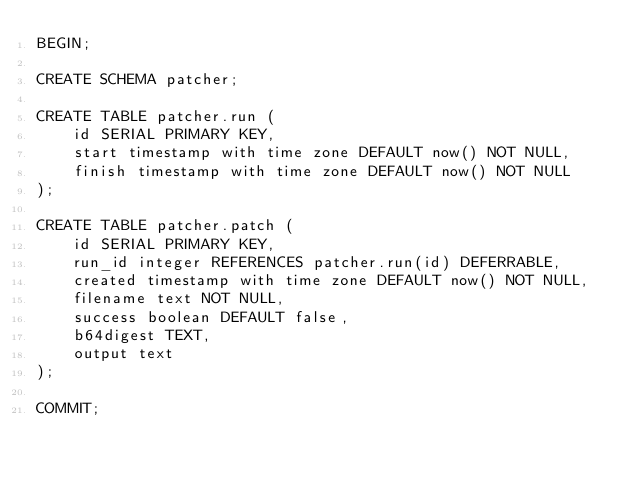Convert code to text. <code><loc_0><loc_0><loc_500><loc_500><_SQL_>BEGIN;

CREATE SCHEMA patcher;

CREATE TABLE patcher.run (
    id SERIAL PRIMARY KEY,
    start timestamp with time zone DEFAULT now() NOT NULL,
    finish timestamp with time zone DEFAULT now() NOT NULL
);

CREATE TABLE patcher.patch (
    id SERIAL PRIMARY KEY,
    run_id integer REFERENCES patcher.run(id) DEFERRABLE,
    created timestamp with time zone DEFAULT now() NOT NULL,
    filename text NOT NULL,
    success boolean DEFAULT false,
    b64digest TEXT,
    output text
);

COMMIT;
</code> 